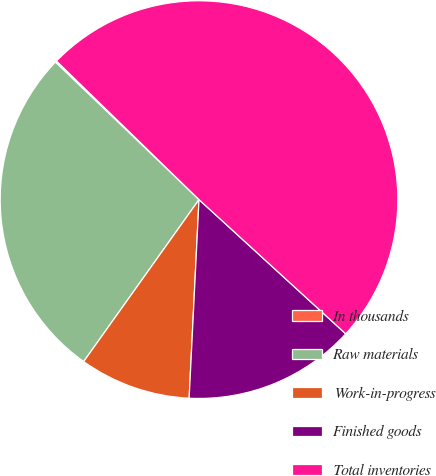<chart> <loc_0><loc_0><loc_500><loc_500><pie_chart><fcel>In thousands<fcel>Raw materials<fcel>Work-in-progress<fcel>Finished goods<fcel>Total inventories<nl><fcel>0.12%<fcel>27.31%<fcel>9.06%<fcel>14.0%<fcel>49.52%<nl></chart> 